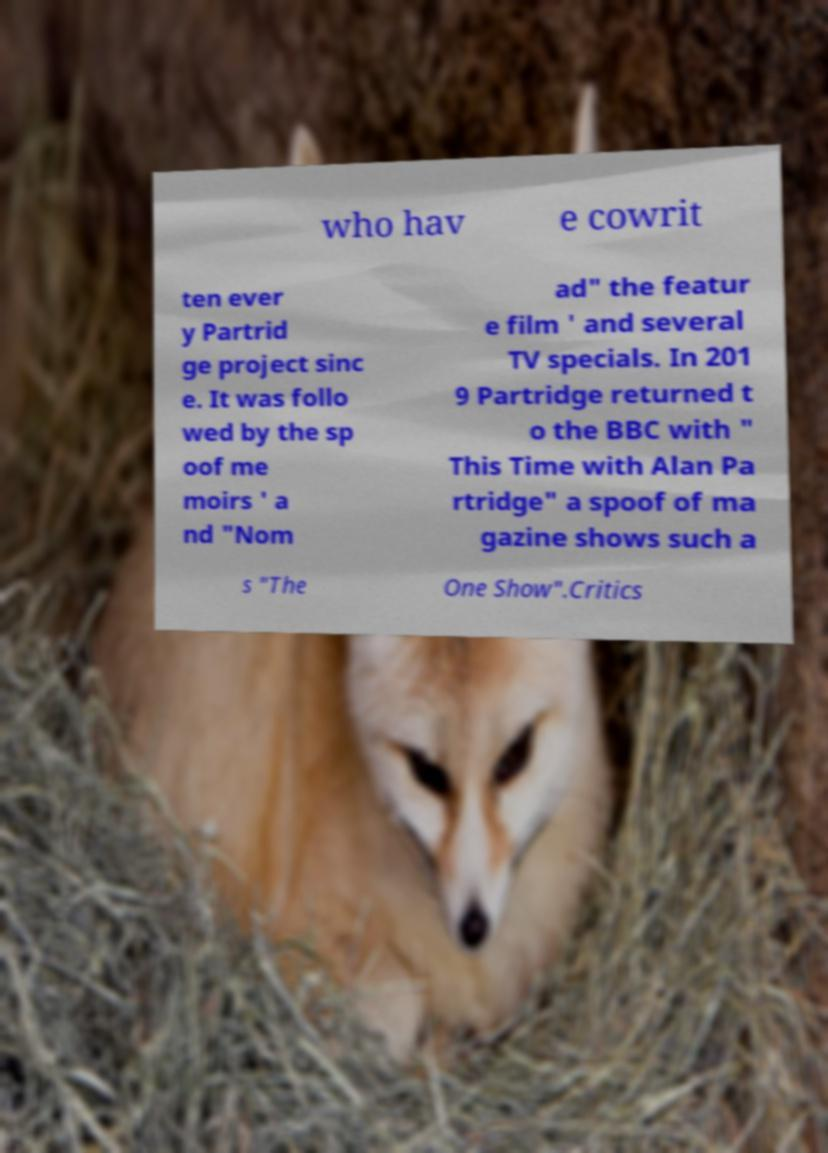Can you accurately transcribe the text from the provided image for me? who hav e cowrit ten ever y Partrid ge project sinc e. It was follo wed by the sp oof me moirs ' a nd "Nom ad" the featur e film ' and several TV specials. In 201 9 Partridge returned t o the BBC with " This Time with Alan Pa rtridge" a spoof of ma gazine shows such a s "The One Show".Critics 